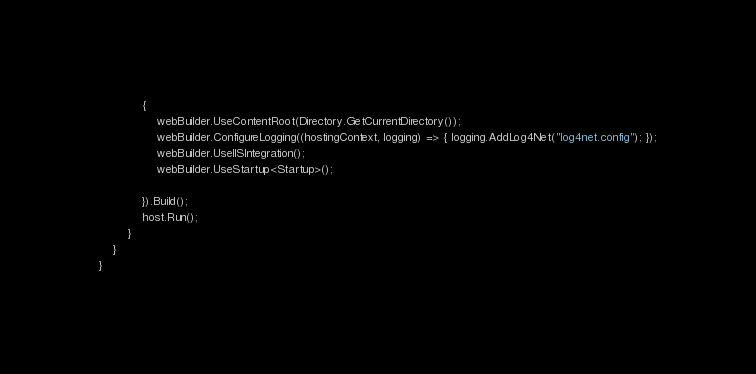Convert code to text. <code><loc_0><loc_0><loc_500><loc_500><_C#_>            {
                webBuilder.UseContentRoot(Directory.GetCurrentDirectory());
                webBuilder.ConfigureLogging((hostingContext, logging) => { logging.AddLog4Net("log4net.config"); });
                webBuilder.UseIISIntegration();
                webBuilder.UseStartup<Startup>();

            }).Build();
            host.Run();
        }
    }
}
</code> 